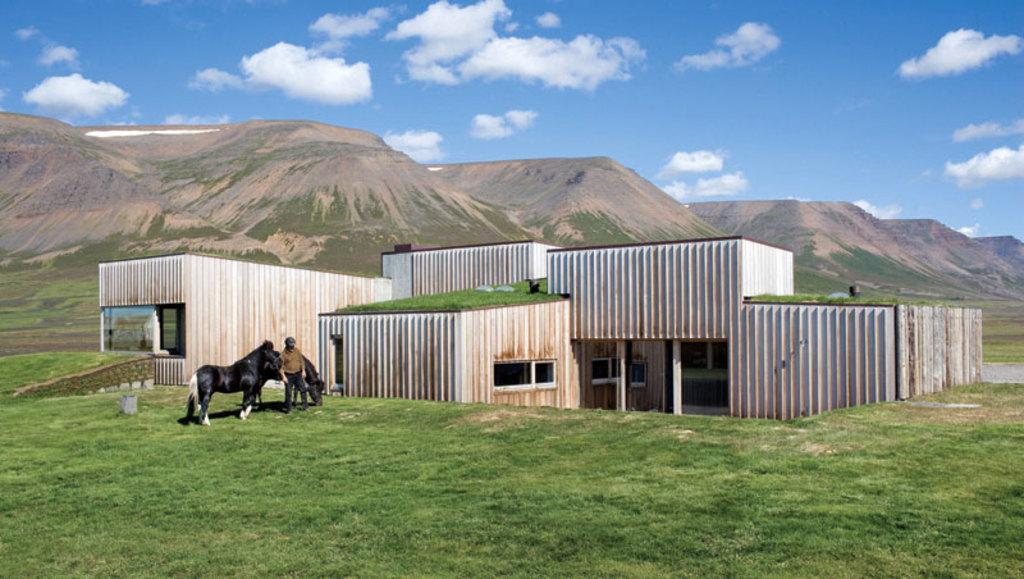What type of structures are present in the image? There are sheds in the image. What other living beings can be seen in the image? There are animals in the image. What type of vegetation is present in the image? There is grass in the image. Is there a person in the image? Yes, there is a person in the image. What type of landscape feature is visible in the image? There are mountains in the image. What is the condition of the sky in the image? The sky is visible in the background of the image, and it appears to be cloudy. What type of power is being generated in the image? There is no indication of power generation in the image. Where is the bedroom located in the image? There is no bedroom present in the image. 